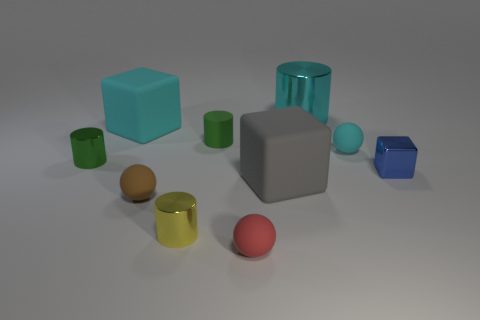Subtract all large gray rubber cubes. How many cubes are left? 2 Subtract 2 balls. How many balls are left? 1 Subtract all cyan blocks. How many blocks are left? 2 Subtract all small cyan matte balls. Subtract all tiny green objects. How many objects are left? 7 Add 5 tiny rubber objects. How many tiny rubber objects are left? 9 Add 8 brown rubber cylinders. How many brown rubber cylinders exist? 8 Subtract 0 green spheres. How many objects are left? 10 Subtract all cubes. How many objects are left? 7 Subtract all green blocks. Subtract all red cylinders. How many blocks are left? 3 Subtract all purple spheres. How many yellow cylinders are left? 1 